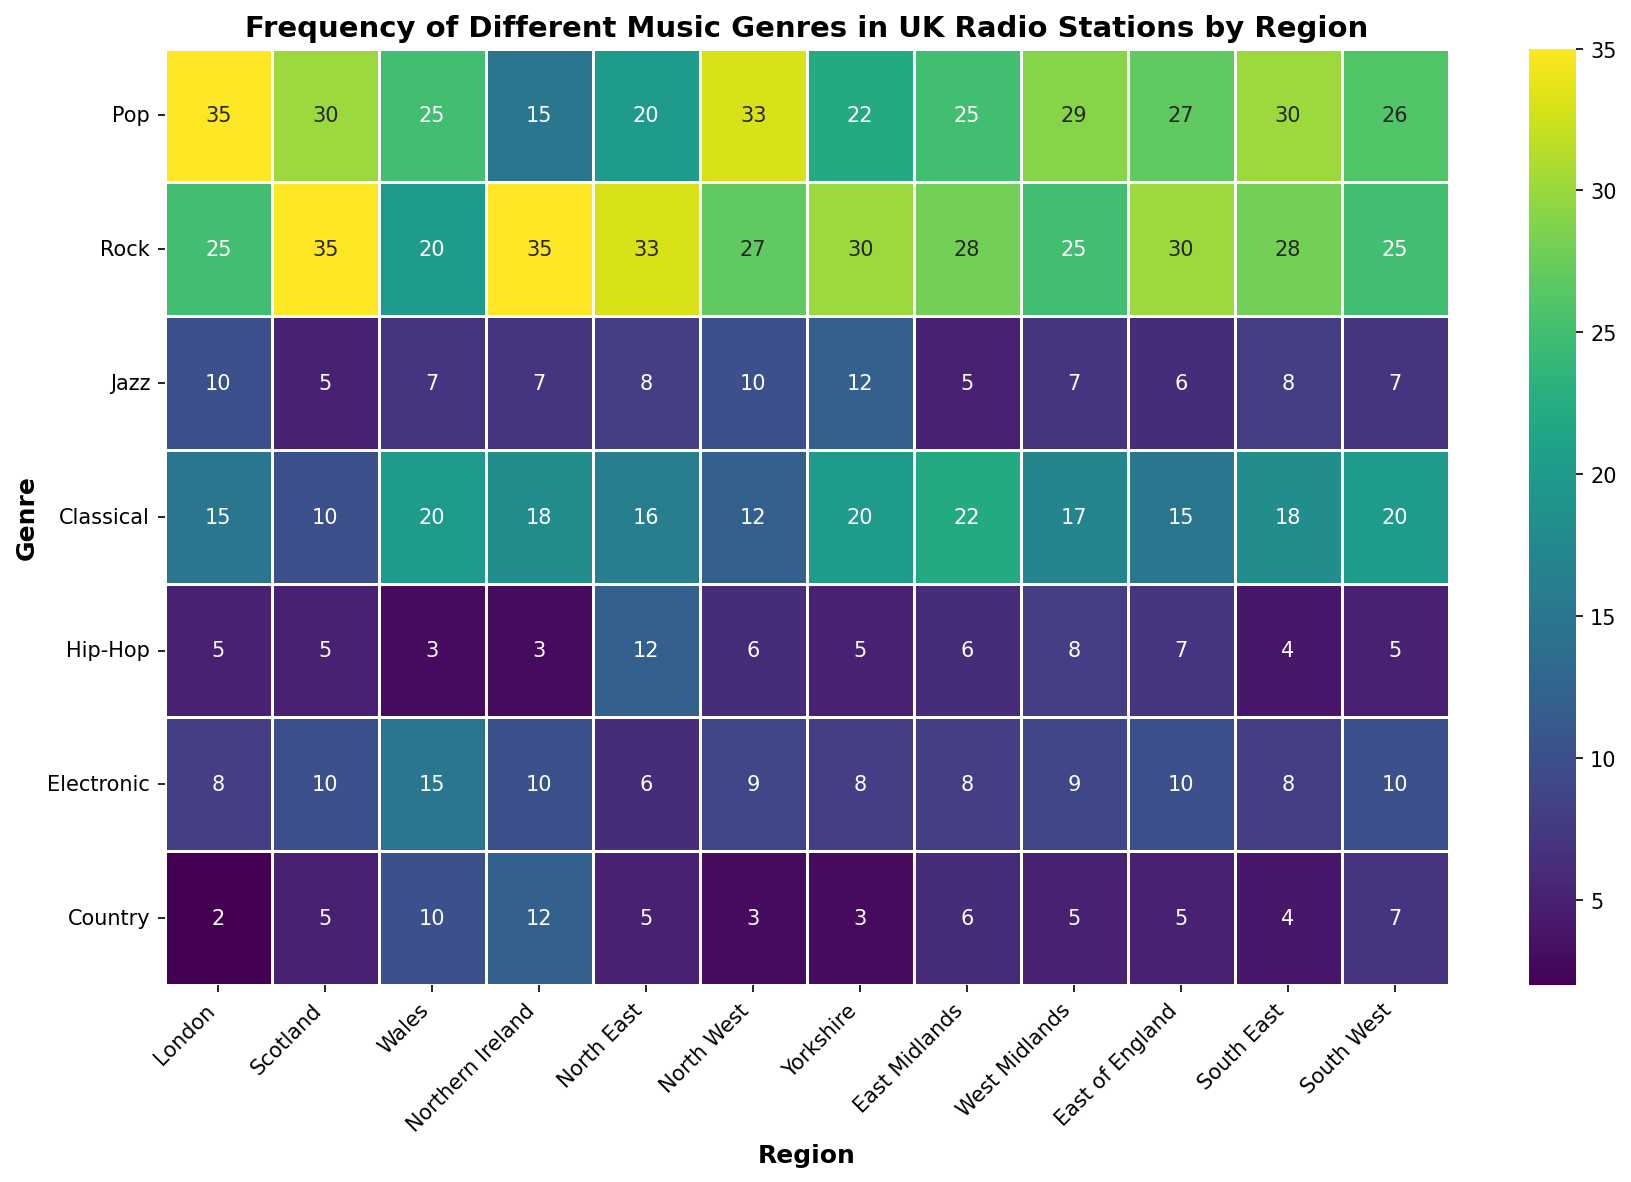Which region has the highest frequency of the Rock genre? Look at the Rock genre row and identify the highest value. The highest value in the Rock row is 35, found in Scotland and Northern Ireland.
Answer: Scotland and Northern Ireland Which region has the least frequency of the Jazz genre? Look at the Jazz genre row and find the smallest value. The smallest value in the Jazz row is 5, found in Scotland and East Midlands.
Answer: Scotland and East Midlands What's the average frequency of Classical music across all regions? Sum all values in the Classical row (15 + 10 + 20 + 18 + 16 + 12 + 20 + 22 + 17 + 15 + 18 + 20 = 203) and divide by the number of regions (12). The average is 203/12 ≈ 16.92.
Answer: 16.92 Which region shows the most variety in genre frequencies? Look at the range (difference between the highest and lowest frequencies) for each region. London, for example, ranges from 2 (Country) to 35 (Pop), a range of 33. Compare this value across regions. The highest range is found by comparing all regions, where Scotland has the highest variety (Range: 35 (Rock) to 5 (Jazz and Hip-Hop), which is a range of 30).
Answer: London and Scotland Which genre has the most consistent frequency across regions? Check the variance or range of values for each genre. A smaller range indicates more consistency. Pop ranges from 15 to 35, Rock from 20 to 35, Jazz from 5 to 12, Classical from 10 to 22, Hip-Hop from 3 to 12, Electronic from 6 to 15, and Country from 2 to 12. Jazz has the smallest range (5 to 12), so it is the most consistent.
Answer: Jazz Which region has the highest total frequency across all genres? Sum the frequencies for each region and compare. For example, London has (35 + 25 + 10 + 15 + 5 + 8 + 2 = 100). Repeat for all regions and compare. The region with the highest total is Northern Ireland (15 + 35 + 7 + 18 + 3 + 10 + 12 = 100).
Answer: London and Northern Ireland In which region are Electronic and Hip-Hop frequencies equal? Compare the values of Electronic and Hip-Hop genres for each region. In North West, Electronic (9) and Hip-Hop (9) frequencies are equal.
Answer: North West Which two regions have the closest frequency values for Country music? Compare the values in the Country row to find the two closest points. Wales (10) and West Midlands (5) have close values in terms of smaller difference compared to other regions. The closest two values are found to be in East Midlands (6) and North East (5), which have a difference of 1.
Answer: East Midlands and North East Which genre is the least frequently played in North East? Look at the North East column and find the smallest value. The Jazz genre has the smallest frequency (8) among North East genres.
Answer: Jazz What is the combined frequency of Pop in all Southern regions (South East and South West)? Sum the frequencies of Pop in South East and South West. South East has 30 and South West has 26, so the combined frequency is (30 + 26 = 56).
Answer: 56 